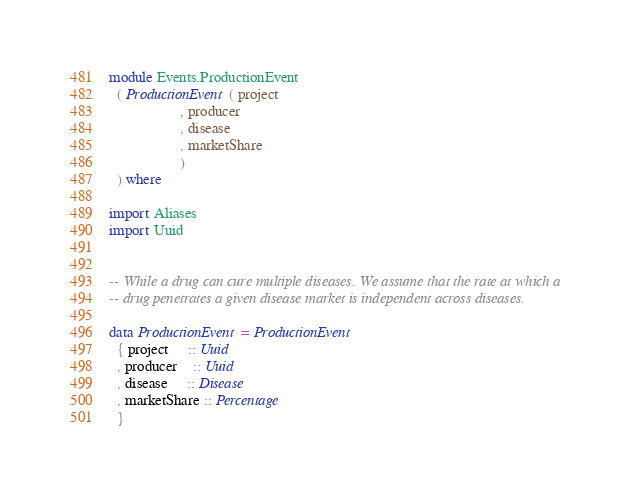Convert code to text. <code><loc_0><loc_0><loc_500><loc_500><_Haskell_>module Events.ProductionEvent
  ( ProductionEvent ( project
                   , producer
                   , disease
                   , marketShare
                   )
  ) where

import Aliases
import Uuid


-- While a drug can cure multiple diseases. We assume that the rate at which a
-- drug penetrates a given disease market is independent across diseases.

data ProductionEvent = ProductionEvent
  { project     :: Uuid
  , producer    :: Uuid
  , disease     :: Disease
  , marketShare :: Percentage
  }
</code> 